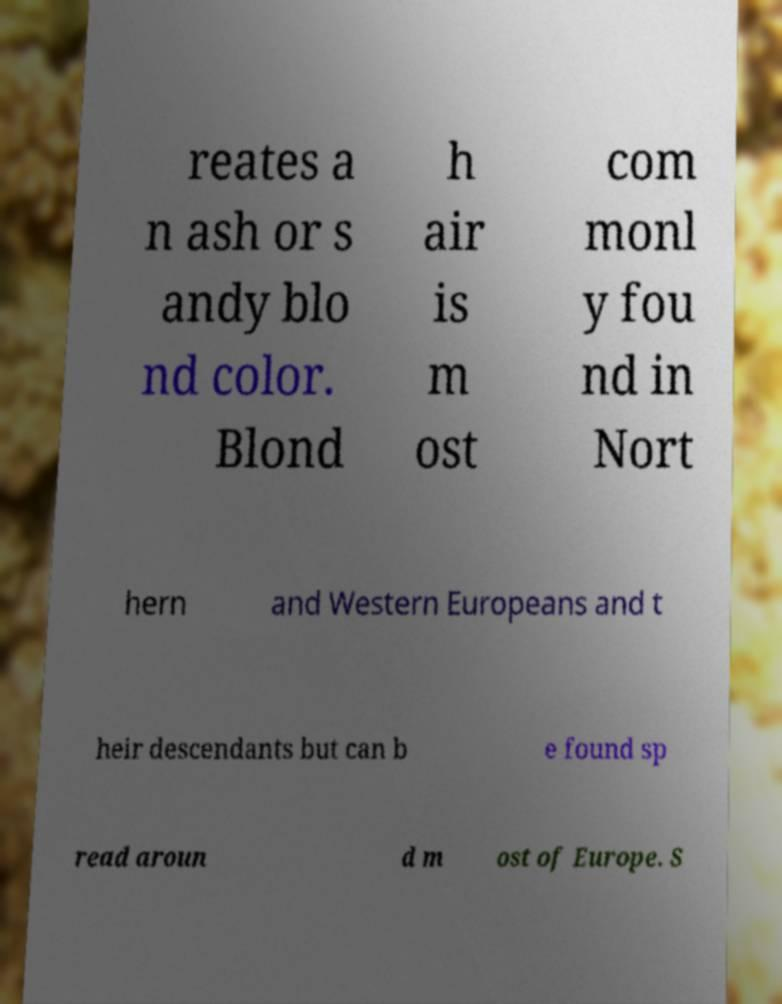There's text embedded in this image that I need extracted. Can you transcribe it verbatim? reates a n ash or s andy blo nd color. Blond h air is m ost com monl y fou nd in Nort hern and Western Europeans and t heir descendants but can b e found sp read aroun d m ost of Europe. S 